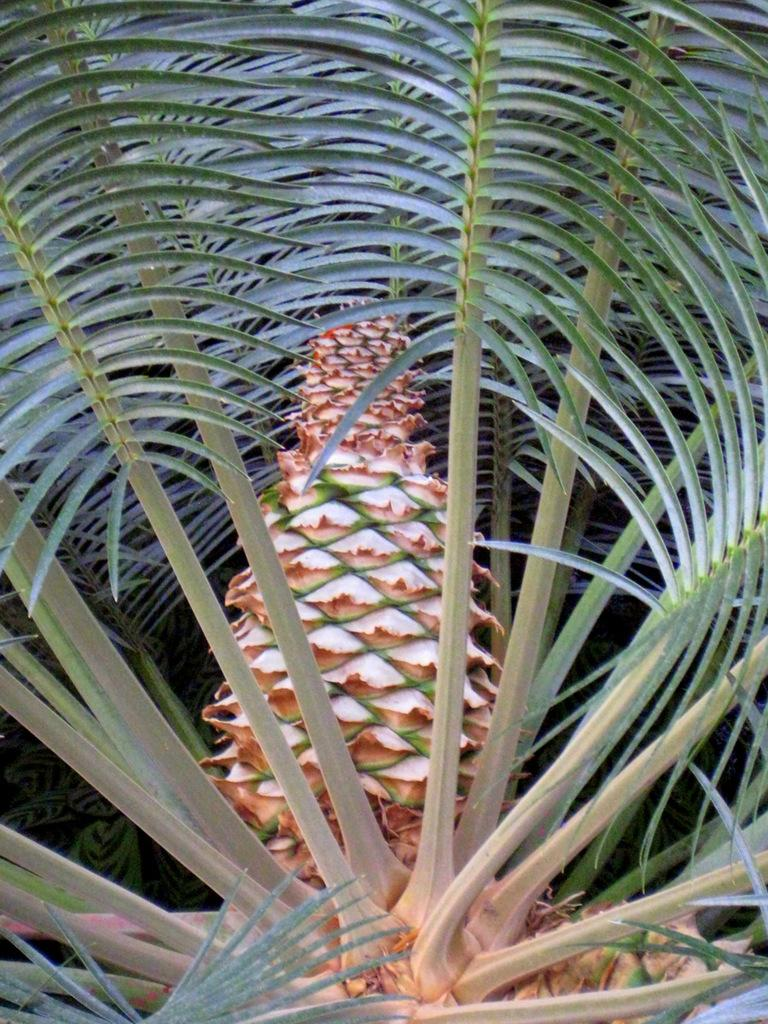What type of living organism can be seen in the image? There is a plant in the image. How does the plant start its day in the image? The image does not provide information about the plant's daily routine or activities, so it cannot be determined how the plant starts its day. 